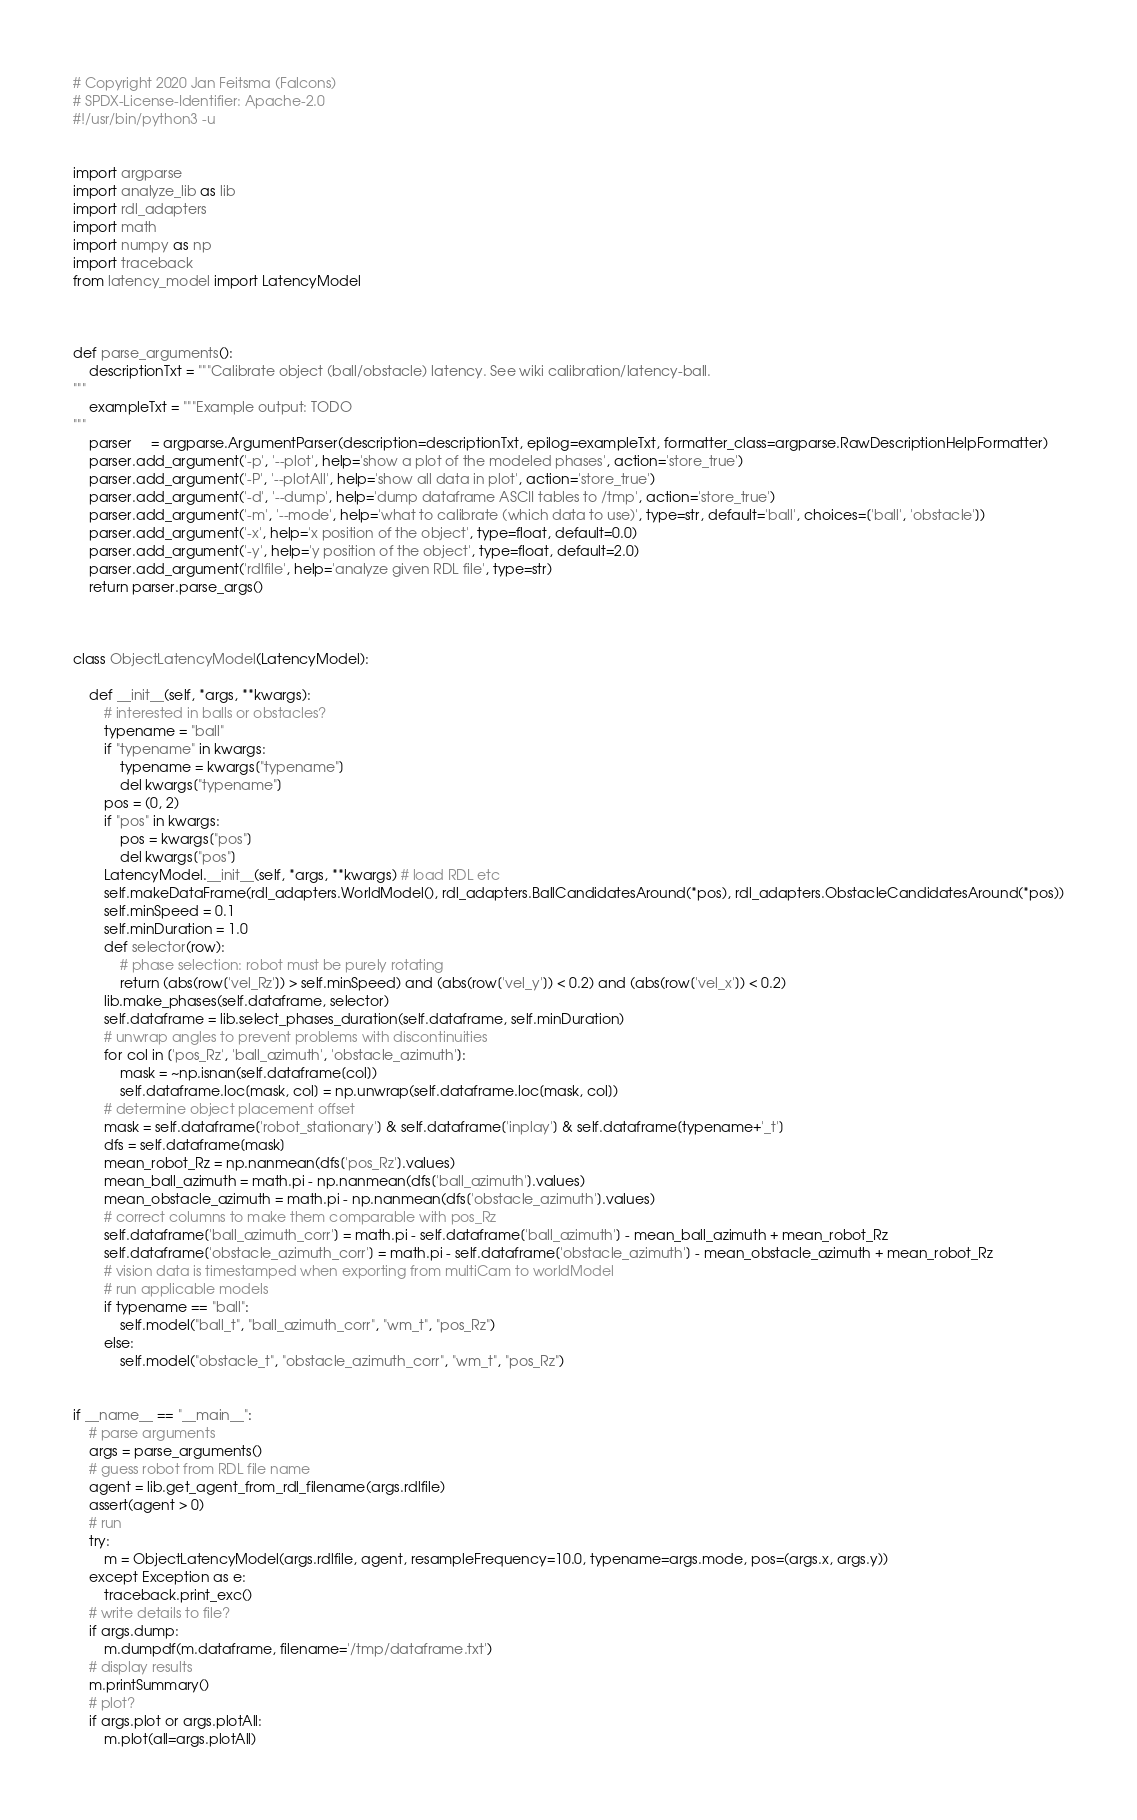Convert code to text. <code><loc_0><loc_0><loc_500><loc_500><_Python_># Copyright 2020 Jan Feitsma (Falcons)
# SPDX-License-Identifier: Apache-2.0
#!/usr/bin/python3 -u


import argparse
import analyze_lib as lib
import rdl_adapters
import math
import numpy as np
import traceback
from latency_model import LatencyModel



def parse_arguments():
    descriptionTxt = """Calibrate object (ball/obstacle) latency. See wiki calibration/latency-ball.
"""
    exampleTxt = """Example output: TODO
"""
    parser     = argparse.ArgumentParser(description=descriptionTxt, epilog=exampleTxt, formatter_class=argparse.RawDescriptionHelpFormatter)
    parser.add_argument('-p', '--plot', help='show a plot of the modeled phases', action='store_true')
    parser.add_argument('-P', '--plotAll', help='show all data in plot', action='store_true')
    parser.add_argument('-d', '--dump', help='dump dataframe ASCII tables to /tmp', action='store_true')
    parser.add_argument('-m', '--mode', help='what to calibrate (which data to use)', type=str, default='ball', choices=['ball', 'obstacle'])
    parser.add_argument('-x', help='x position of the object', type=float, default=0.0)
    parser.add_argument('-y', help='y position of the object', type=float, default=2.0)
    parser.add_argument('rdlfile', help='analyze given RDL file', type=str)
    return parser.parse_args()



class ObjectLatencyModel(LatencyModel):

    def __init__(self, *args, **kwargs):
        # interested in balls or obstacles?
        typename = "ball"
        if "typename" in kwargs:
            typename = kwargs["typename"]
            del kwargs["typename"]
        pos = (0, 2)
        if "pos" in kwargs:
            pos = kwargs["pos"]
            del kwargs["pos"]
        LatencyModel.__init__(self, *args, **kwargs) # load RDL etc
        self.makeDataFrame(rdl_adapters.WorldModel(), rdl_adapters.BallCandidatesAround(*pos), rdl_adapters.ObstacleCandidatesAround(*pos))
        self.minSpeed = 0.1
        self.minDuration = 1.0
        def selector(row):
            # phase selection: robot must be purely rotating
            return (abs(row['vel_Rz']) > self.minSpeed) and (abs(row['vel_y']) < 0.2) and (abs(row['vel_x']) < 0.2)
        lib.make_phases(self.dataframe, selector)
        self.dataframe = lib.select_phases_duration(self.dataframe, self.minDuration)
        # unwrap angles to prevent problems with discontinuities
        for col in ['pos_Rz', 'ball_azimuth', 'obstacle_azimuth']:
            mask = ~np.isnan(self.dataframe[col])
            self.dataframe.loc[mask, col] = np.unwrap(self.dataframe.loc[mask, col])
        # determine object placement offset
        mask = self.dataframe['robot_stationary'] & self.dataframe['inplay'] & self.dataframe[typename+'_t']
        dfs = self.dataframe[mask]
        mean_robot_Rz = np.nanmean(dfs['pos_Rz'].values)
        mean_ball_azimuth = math.pi - np.nanmean(dfs['ball_azimuth'].values)
        mean_obstacle_azimuth = math.pi - np.nanmean(dfs['obstacle_azimuth'].values)
        # correct columns to make them comparable with pos_Rz
        self.dataframe['ball_azimuth_corr'] = math.pi - self.dataframe['ball_azimuth'] - mean_ball_azimuth + mean_robot_Rz
        self.dataframe['obstacle_azimuth_corr'] = math.pi - self.dataframe['obstacle_azimuth'] - mean_obstacle_azimuth + mean_robot_Rz
        # vision data is timestamped when exporting from multiCam to worldModel
        # run applicable models
        if typename == "ball":
            self.model("ball_t", "ball_azimuth_corr", "wm_t", "pos_Rz")
        else:
            self.model("obstacle_t", "obstacle_azimuth_corr", "wm_t", "pos_Rz")


if __name__ == "__main__":
    # parse arguments
    args = parse_arguments()
    # guess robot from RDL file name
    agent = lib.get_agent_from_rdl_filename(args.rdlfile)
    assert(agent > 0)
    # run
    try:
        m = ObjectLatencyModel(args.rdlfile, agent, resampleFrequency=10.0, typename=args.mode, pos=(args.x, args.y))
    except Exception as e:
        traceback.print_exc()
    # write details to file?
    if args.dump:
        m.dumpdf(m.dataframe, filename='/tmp/dataframe.txt')
    # display results
    m.printSummary()
    # plot?
    if args.plot or args.plotAll:
        m.plot(all=args.plotAll)

</code> 